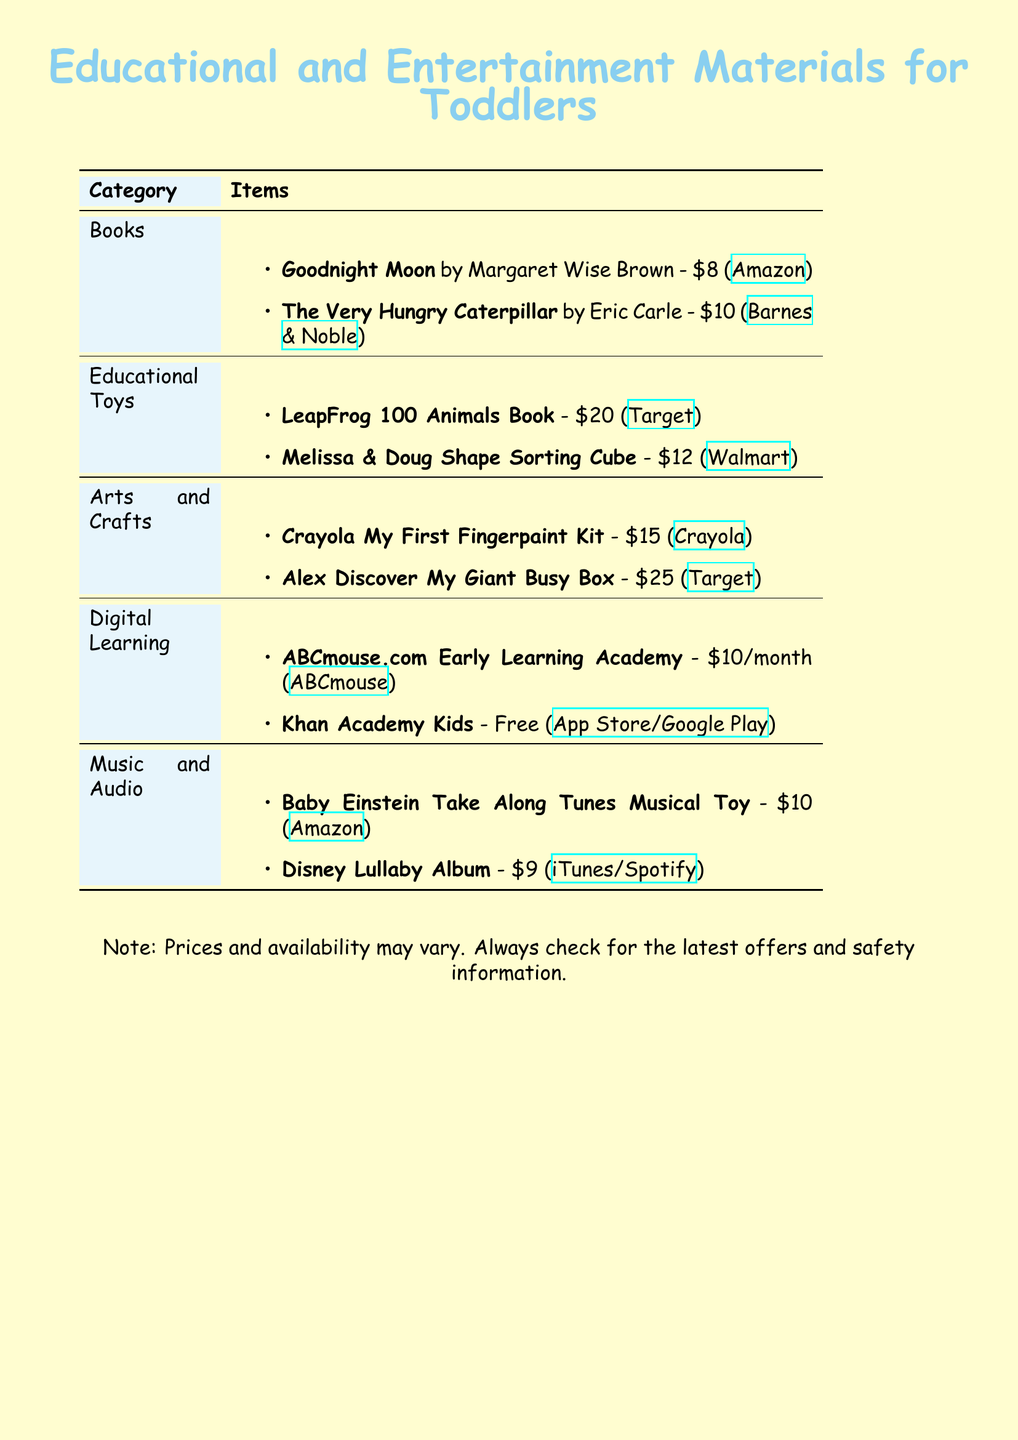What is the price of "Goodnight Moon"? The price of "Goodnight Moon" is listed in the document next to the book title.
Answer: $8 What educational toy costs $20? The toy costing $20 is mentioned in the Educational Toys section, which specifies the price next to the toy name.
Answer: LeapFrog 100 Animals Book How many books are listed in the document? The document includes a section for Books and counts the items listed there to derive the total.
Answer: 2 What is the monthly cost of ABCmouse.com? The document specifies the cost of ABCmouse.com in the Digital Learning section, which can be found next to the item description.
Answer: $10/month Which item from the Arts and Crafts category is the most expensive? The prices of items in the Arts and Crafts section are compared to identify the one with the highest price.
Answer: Alex Discover My Giant Busy Box How much does the Disney Lullaby Album cost? The document provides the price next to the item name in the Music and Audio section.
Answer: $9 Which digital learning app is free? The document specifies one item in the Digital Learning section that is labeled as free.
Answer: Khan Academy Kids What color theme is used for the document background? The document describes the page color in the introductory section, giving an indication of its theme.
Answer: Soft yellow 